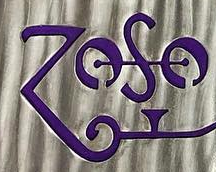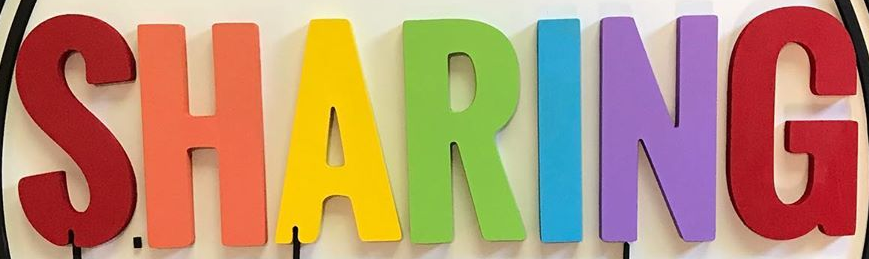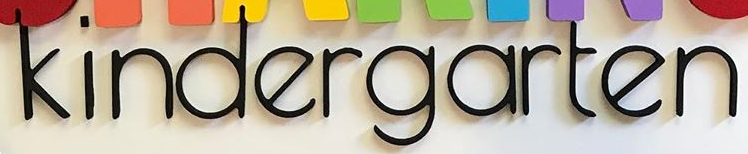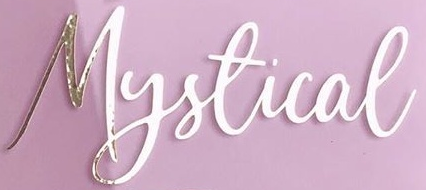Read the text from these images in sequence, separated by a semicolon. ZOSO; SHARING; kindergarten; Mystical 